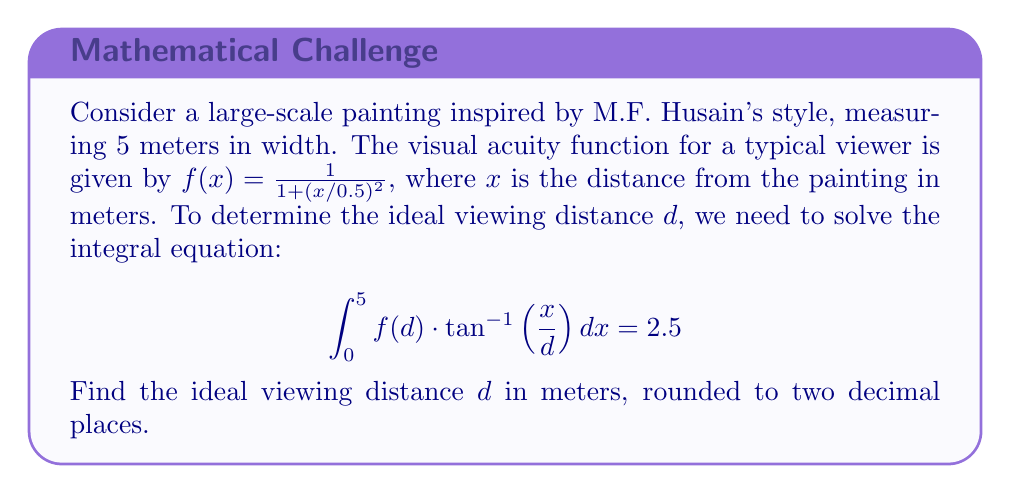Solve this math problem. To solve this problem, we'll follow these steps:

1) First, let's simplify the integral equation by substituting the given function $f(x)$:

   $$\int_0^5 \frac{1}{1 + (d/0.5)^2} \cdot \tan^{-1}\left(\frac{x}{d}\right) dx = 2.5$$

2) The term $\frac{1}{1 + (d/0.5)^2}$ is constant with respect to $x$, so we can take it out of the integral:

   $$\frac{1}{1 + (d/0.5)^2} \cdot \int_0^5 \tan^{-1}\left(\frac{x}{d}\right) dx = 2.5$$

3) Now, let's solve the integral. We can use the substitution $u = \frac{x}{d}$, $du = \frac{1}{d}dx$:

   $$\frac{1}{1 + (d/0.5)^2} \cdot d \cdot \int_0^{5/d} \tan^{-1}(u) du = 2.5$$

4) The integral of $\tan^{-1}(u)$ is $u \tan^{-1}(u) - \frac{1}{2}\ln(1+u^2) + C$. Applying this:

   $$\frac{1}{1 + (d/0.5)^2} \cdot d \cdot \left[u \tan^{-1}(u) - \frac{1}{2}\ln(1+u^2)\right]_0^{5/d} = 2.5$$

5) Evaluating the integral:

   $$\frac{1}{1 + (d/0.5)^2} \cdot d \cdot \left[\frac{5}{d} \tan^{-1}\left(\frac{5}{d}\right) - \frac{1}{2}\ln\left(1+\left(\frac{5}{d}\right)^2\right)\right] = 2.5$$

6) This equation cannot be solved analytically. We need to use numerical methods to find $d$. Using a numerical solver, we find that $d \approx 3.91$ meters.
Answer: 3.91 meters 